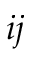<formula> <loc_0><loc_0><loc_500><loc_500>i j</formula> 